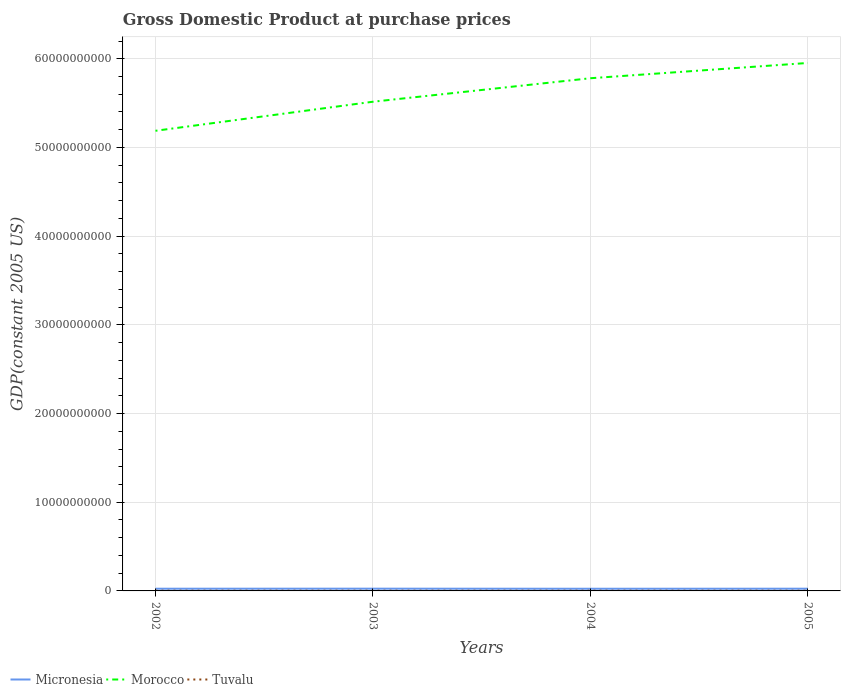Across all years, what is the maximum GDP at purchase prices in Morocco?
Make the answer very short. 5.19e+1. In which year was the GDP at purchase prices in Morocco maximum?
Offer a very short reply. 2002. What is the total GDP at purchase prices in Tuvalu in the graph?
Ensure brevity in your answer.  1.17e+06. What is the difference between the highest and the second highest GDP at purchase prices in Morocco?
Offer a very short reply. 7.65e+09. Is the GDP at purchase prices in Micronesia strictly greater than the GDP at purchase prices in Morocco over the years?
Your answer should be very brief. Yes. How many lines are there?
Make the answer very short. 3. How many years are there in the graph?
Provide a succinct answer. 4. What is the difference between two consecutive major ticks on the Y-axis?
Your answer should be compact. 1.00e+1. Are the values on the major ticks of Y-axis written in scientific E-notation?
Your response must be concise. No. How are the legend labels stacked?
Offer a terse response. Horizontal. What is the title of the graph?
Provide a short and direct response. Gross Domestic Product at purchase prices. Does "Pacific island small states" appear as one of the legend labels in the graph?
Your response must be concise. No. What is the label or title of the Y-axis?
Ensure brevity in your answer.  GDP(constant 2005 US). What is the GDP(constant 2005 US) in Micronesia in 2002?
Give a very brief answer. 2.48e+08. What is the GDP(constant 2005 US) of Morocco in 2002?
Your answer should be very brief. 5.19e+1. What is the GDP(constant 2005 US) of Tuvalu in 2002?
Your response must be concise. 2.38e+07. What is the GDP(constant 2005 US) in Micronesia in 2003?
Give a very brief answer. 2.53e+08. What is the GDP(constant 2005 US) in Morocco in 2003?
Offer a terse response. 5.52e+1. What is the GDP(constant 2005 US) in Tuvalu in 2003?
Provide a short and direct response. 2.30e+07. What is the GDP(constant 2005 US) in Micronesia in 2004?
Provide a short and direct response. 2.45e+08. What is the GDP(constant 2005 US) of Morocco in 2004?
Ensure brevity in your answer.  5.78e+1. What is the GDP(constant 2005 US) of Tuvalu in 2004?
Keep it short and to the point. 2.27e+07. What is the GDP(constant 2005 US) of Micronesia in 2005?
Your answer should be compact. 2.50e+08. What is the GDP(constant 2005 US) of Morocco in 2005?
Ensure brevity in your answer.  5.95e+1. What is the GDP(constant 2005 US) in Tuvalu in 2005?
Your answer should be compact. 2.18e+07. Across all years, what is the maximum GDP(constant 2005 US) of Micronesia?
Make the answer very short. 2.53e+08. Across all years, what is the maximum GDP(constant 2005 US) of Morocco?
Your response must be concise. 5.95e+1. Across all years, what is the maximum GDP(constant 2005 US) of Tuvalu?
Give a very brief answer. 2.38e+07. Across all years, what is the minimum GDP(constant 2005 US) in Micronesia?
Provide a short and direct response. 2.45e+08. Across all years, what is the minimum GDP(constant 2005 US) in Morocco?
Provide a succinct answer. 5.19e+1. Across all years, what is the minimum GDP(constant 2005 US) of Tuvalu?
Ensure brevity in your answer.  2.18e+07. What is the total GDP(constant 2005 US) of Micronesia in the graph?
Your answer should be compact. 9.95e+08. What is the total GDP(constant 2005 US) of Morocco in the graph?
Make the answer very short. 2.24e+11. What is the total GDP(constant 2005 US) of Tuvalu in the graph?
Keep it short and to the point. 9.13e+07. What is the difference between the GDP(constant 2005 US) of Micronesia in 2002 and that in 2003?
Keep it short and to the point. -4.53e+06. What is the difference between the GDP(constant 2005 US) of Morocco in 2002 and that in 2003?
Offer a terse response. -3.28e+09. What is the difference between the GDP(constant 2005 US) in Tuvalu in 2002 and that in 2003?
Ensure brevity in your answer.  7.93e+05. What is the difference between the GDP(constant 2005 US) of Micronesia in 2002 and that in 2004?
Provide a succinct answer. 3.63e+06. What is the difference between the GDP(constant 2005 US) in Morocco in 2002 and that in 2004?
Offer a terse response. -5.93e+09. What is the difference between the GDP(constant 2005 US) of Tuvalu in 2002 and that in 2004?
Give a very brief answer. 1.10e+06. What is the difference between the GDP(constant 2005 US) of Micronesia in 2002 and that in 2005?
Ensure brevity in your answer.  -1.65e+06. What is the difference between the GDP(constant 2005 US) of Morocco in 2002 and that in 2005?
Make the answer very short. -7.65e+09. What is the difference between the GDP(constant 2005 US) in Tuvalu in 2002 and that in 2005?
Keep it short and to the point. 1.96e+06. What is the difference between the GDP(constant 2005 US) in Micronesia in 2003 and that in 2004?
Your answer should be compact. 8.17e+06. What is the difference between the GDP(constant 2005 US) in Morocco in 2003 and that in 2004?
Provide a short and direct response. -2.65e+09. What is the difference between the GDP(constant 2005 US) in Tuvalu in 2003 and that in 2004?
Your answer should be very brief. 3.11e+05. What is the difference between the GDP(constant 2005 US) in Micronesia in 2003 and that in 2005?
Give a very brief answer. 2.88e+06. What is the difference between the GDP(constant 2005 US) of Morocco in 2003 and that in 2005?
Ensure brevity in your answer.  -4.37e+09. What is the difference between the GDP(constant 2005 US) in Tuvalu in 2003 and that in 2005?
Provide a succinct answer. 1.17e+06. What is the difference between the GDP(constant 2005 US) in Micronesia in 2004 and that in 2005?
Provide a succinct answer. -5.28e+06. What is the difference between the GDP(constant 2005 US) of Morocco in 2004 and that in 2005?
Keep it short and to the point. -1.72e+09. What is the difference between the GDP(constant 2005 US) in Tuvalu in 2004 and that in 2005?
Your response must be concise. 8.58e+05. What is the difference between the GDP(constant 2005 US) in Micronesia in 2002 and the GDP(constant 2005 US) in Morocco in 2003?
Provide a short and direct response. -5.49e+1. What is the difference between the GDP(constant 2005 US) of Micronesia in 2002 and the GDP(constant 2005 US) of Tuvalu in 2003?
Ensure brevity in your answer.  2.25e+08. What is the difference between the GDP(constant 2005 US) of Morocco in 2002 and the GDP(constant 2005 US) of Tuvalu in 2003?
Your answer should be compact. 5.19e+1. What is the difference between the GDP(constant 2005 US) in Micronesia in 2002 and the GDP(constant 2005 US) in Morocco in 2004?
Give a very brief answer. -5.76e+1. What is the difference between the GDP(constant 2005 US) of Micronesia in 2002 and the GDP(constant 2005 US) of Tuvalu in 2004?
Give a very brief answer. 2.25e+08. What is the difference between the GDP(constant 2005 US) of Morocco in 2002 and the GDP(constant 2005 US) of Tuvalu in 2004?
Offer a very short reply. 5.19e+1. What is the difference between the GDP(constant 2005 US) of Micronesia in 2002 and the GDP(constant 2005 US) of Morocco in 2005?
Provide a succinct answer. -5.93e+1. What is the difference between the GDP(constant 2005 US) of Micronesia in 2002 and the GDP(constant 2005 US) of Tuvalu in 2005?
Give a very brief answer. 2.26e+08. What is the difference between the GDP(constant 2005 US) in Morocco in 2002 and the GDP(constant 2005 US) in Tuvalu in 2005?
Ensure brevity in your answer.  5.19e+1. What is the difference between the GDP(constant 2005 US) of Micronesia in 2003 and the GDP(constant 2005 US) of Morocco in 2004?
Keep it short and to the point. -5.75e+1. What is the difference between the GDP(constant 2005 US) in Micronesia in 2003 and the GDP(constant 2005 US) in Tuvalu in 2004?
Keep it short and to the point. 2.30e+08. What is the difference between the GDP(constant 2005 US) of Morocco in 2003 and the GDP(constant 2005 US) of Tuvalu in 2004?
Keep it short and to the point. 5.51e+1. What is the difference between the GDP(constant 2005 US) in Micronesia in 2003 and the GDP(constant 2005 US) in Morocco in 2005?
Give a very brief answer. -5.93e+1. What is the difference between the GDP(constant 2005 US) of Micronesia in 2003 and the GDP(constant 2005 US) of Tuvalu in 2005?
Your response must be concise. 2.31e+08. What is the difference between the GDP(constant 2005 US) of Morocco in 2003 and the GDP(constant 2005 US) of Tuvalu in 2005?
Offer a very short reply. 5.51e+1. What is the difference between the GDP(constant 2005 US) of Micronesia in 2004 and the GDP(constant 2005 US) of Morocco in 2005?
Your answer should be very brief. -5.93e+1. What is the difference between the GDP(constant 2005 US) of Micronesia in 2004 and the GDP(constant 2005 US) of Tuvalu in 2005?
Provide a short and direct response. 2.23e+08. What is the difference between the GDP(constant 2005 US) of Morocco in 2004 and the GDP(constant 2005 US) of Tuvalu in 2005?
Ensure brevity in your answer.  5.78e+1. What is the average GDP(constant 2005 US) in Micronesia per year?
Give a very brief answer. 2.49e+08. What is the average GDP(constant 2005 US) of Morocco per year?
Provide a succinct answer. 5.61e+1. What is the average GDP(constant 2005 US) in Tuvalu per year?
Make the answer very short. 2.28e+07. In the year 2002, what is the difference between the GDP(constant 2005 US) in Micronesia and GDP(constant 2005 US) in Morocco?
Offer a terse response. -5.16e+1. In the year 2002, what is the difference between the GDP(constant 2005 US) in Micronesia and GDP(constant 2005 US) in Tuvalu?
Make the answer very short. 2.24e+08. In the year 2002, what is the difference between the GDP(constant 2005 US) in Morocco and GDP(constant 2005 US) in Tuvalu?
Your answer should be compact. 5.19e+1. In the year 2003, what is the difference between the GDP(constant 2005 US) of Micronesia and GDP(constant 2005 US) of Morocco?
Offer a very short reply. -5.49e+1. In the year 2003, what is the difference between the GDP(constant 2005 US) in Micronesia and GDP(constant 2005 US) in Tuvalu?
Give a very brief answer. 2.30e+08. In the year 2003, what is the difference between the GDP(constant 2005 US) of Morocco and GDP(constant 2005 US) of Tuvalu?
Your answer should be compact. 5.51e+1. In the year 2004, what is the difference between the GDP(constant 2005 US) in Micronesia and GDP(constant 2005 US) in Morocco?
Offer a very short reply. -5.76e+1. In the year 2004, what is the difference between the GDP(constant 2005 US) in Micronesia and GDP(constant 2005 US) in Tuvalu?
Ensure brevity in your answer.  2.22e+08. In the year 2004, what is the difference between the GDP(constant 2005 US) of Morocco and GDP(constant 2005 US) of Tuvalu?
Your response must be concise. 5.78e+1. In the year 2005, what is the difference between the GDP(constant 2005 US) of Micronesia and GDP(constant 2005 US) of Morocco?
Offer a very short reply. -5.93e+1. In the year 2005, what is the difference between the GDP(constant 2005 US) of Micronesia and GDP(constant 2005 US) of Tuvalu?
Your response must be concise. 2.28e+08. In the year 2005, what is the difference between the GDP(constant 2005 US) in Morocco and GDP(constant 2005 US) in Tuvalu?
Provide a short and direct response. 5.95e+1. What is the ratio of the GDP(constant 2005 US) in Micronesia in 2002 to that in 2003?
Give a very brief answer. 0.98. What is the ratio of the GDP(constant 2005 US) in Morocco in 2002 to that in 2003?
Make the answer very short. 0.94. What is the ratio of the GDP(constant 2005 US) in Tuvalu in 2002 to that in 2003?
Your response must be concise. 1.03. What is the ratio of the GDP(constant 2005 US) of Micronesia in 2002 to that in 2004?
Offer a terse response. 1.01. What is the ratio of the GDP(constant 2005 US) in Morocco in 2002 to that in 2004?
Give a very brief answer. 0.9. What is the ratio of the GDP(constant 2005 US) in Tuvalu in 2002 to that in 2004?
Your answer should be compact. 1.05. What is the ratio of the GDP(constant 2005 US) of Morocco in 2002 to that in 2005?
Keep it short and to the point. 0.87. What is the ratio of the GDP(constant 2005 US) in Tuvalu in 2002 to that in 2005?
Your response must be concise. 1.09. What is the ratio of the GDP(constant 2005 US) in Micronesia in 2003 to that in 2004?
Give a very brief answer. 1.03. What is the ratio of the GDP(constant 2005 US) in Morocco in 2003 to that in 2004?
Offer a terse response. 0.95. What is the ratio of the GDP(constant 2005 US) in Tuvalu in 2003 to that in 2004?
Offer a terse response. 1.01. What is the ratio of the GDP(constant 2005 US) in Micronesia in 2003 to that in 2005?
Your response must be concise. 1.01. What is the ratio of the GDP(constant 2005 US) in Morocco in 2003 to that in 2005?
Make the answer very short. 0.93. What is the ratio of the GDP(constant 2005 US) in Tuvalu in 2003 to that in 2005?
Provide a short and direct response. 1.05. What is the ratio of the GDP(constant 2005 US) of Micronesia in 2004 to that in 2005?
Your response must be concise. 0.98. What is the ratio of the GDP(constant 2005 US) in Morocco in 2004 to that in 2005?
Keep it short and to the point. 0.97. What is the ratio of the GDP(constant 2005 US) in Tuvalu in 2004 to that in 2005?
Offer a terse response. 1.04. What is the difference between the highest and the second highest GDP(constant 2005 US) in Micronesia?
Keep it short and to the point. 2.88e+06. What is the difference between the highest and the second highest GDP(constant 2005 US) of Morocco?
Make the answer very short. 1.72e+09. What is the difference between the highest and the second highest GDP(constant 2005 US) in Tuvalu?
Provide a short and direct response. 7.93e+05. What is the difference between the highest and the lowest GDP(constant 2005 US) in Micronesia?
Make the answer very short. 8.17e+06. What is the difference between the highest and the lowest GDP(constant 2005 US) in Morocco?
Offer a very short reply. 7.65e+09. What is the difference between the highest and the lowest GDP(constant 2005 US) of Tuvalu?
Offer a very short reply. 1.96e+06. 